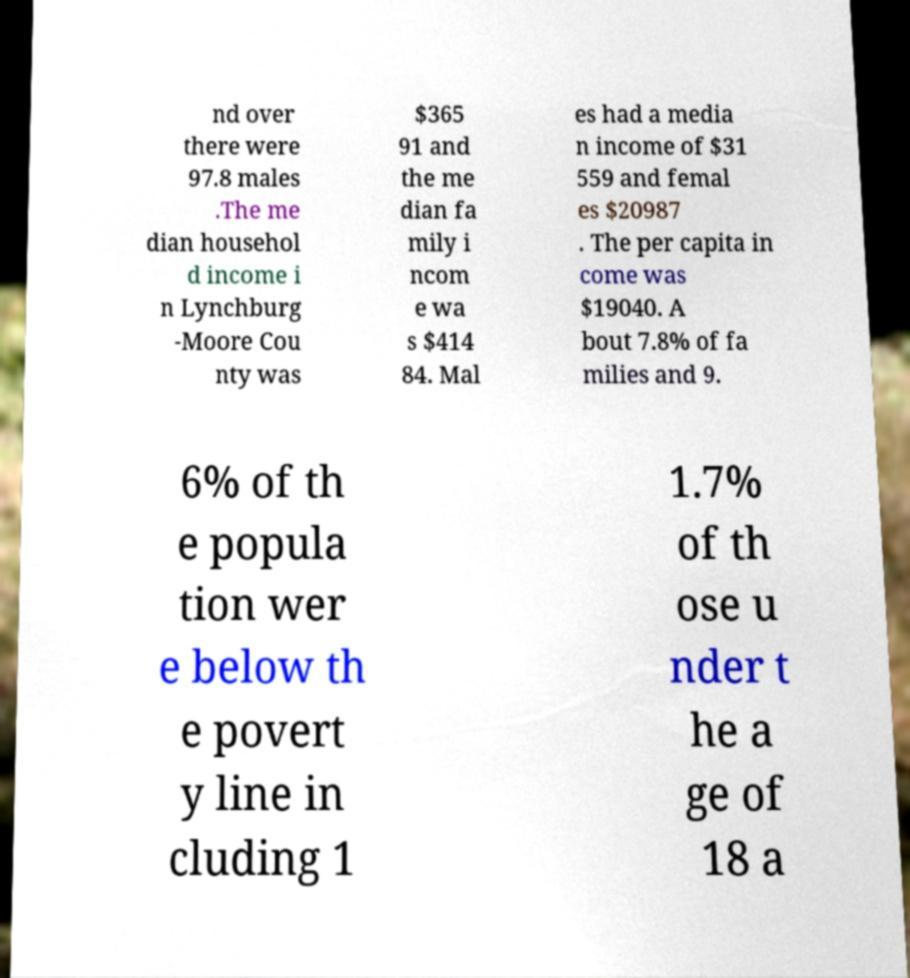Can you accurately transcribe the text from the provided image for me? nd over there were 97.8 males .The me dian househol d income i n Lynchburg -Moore Cou nty was $365 91 and the me dian fa mily i ncom e wa s $414 84. Mal es had a media n income of $31 559 and femal es $20987 . The per capita in come was $19040. A bout 7.8% of fa milies and 9. 6% of th e popula tion wer e below th e povert y line in cluding 1 1.7% of th ose u nder t he a ge of 18 a 